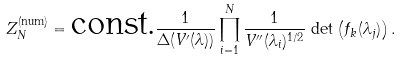<formula> <loc_0><loc_0><loc_500><loc_500>Z _ { N } ^ { \text {(num)} } = \text {const.} \frac { 1 } { \Delta ( V ^ { \prime } ( \lambda ) ) } \prod _ { i = 1 } ^ { N } \frac { 1 } { V ^ { \prime \prime } ( \lambda _ { i } ) ^ { 1 / 2 } } \, \det \left ( f _ { k } ( \lambda _ { j } ) \right ) .</formula> 